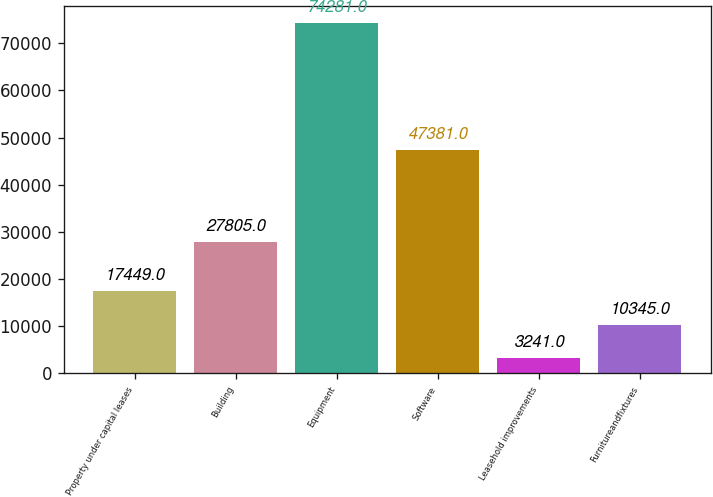Convert chart to OTSL. <chart><loc_0><loc_0><loc_500><loc_500><bar_chart><fcel>Property under capital leases<fcel>Building<fcel>Equipment<fcel>Software<fcel>Leasehold improvements<fcel>Furnitureandfixtures<nl><fcel>17449<fcel>27805<fcel>74281<fcel>47381<fcel>3241<fcel>10345<nl></chart> 